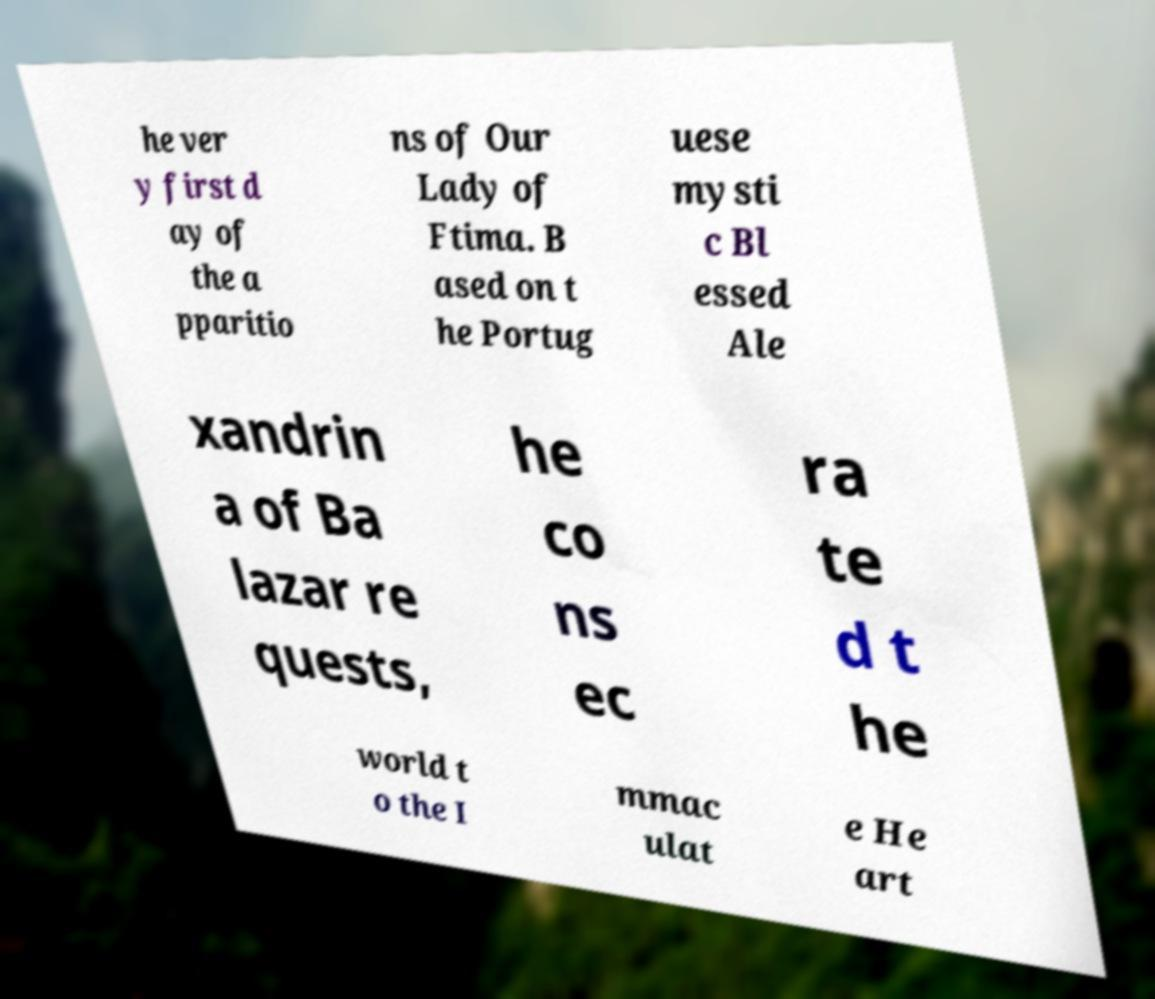Can you read and provide the text displayed in the image?This photo seems to have some interesting text. Can you extract and type it out for me? he ver y first d ay of the a pparitio ns of Our Lady of Ftima. B ased on t he Portug uese mysti c Bl essed Ale xandrin a of Ba lazar re quests, he co ns ec ra te d t he world t o the I mmac ulat e He art 